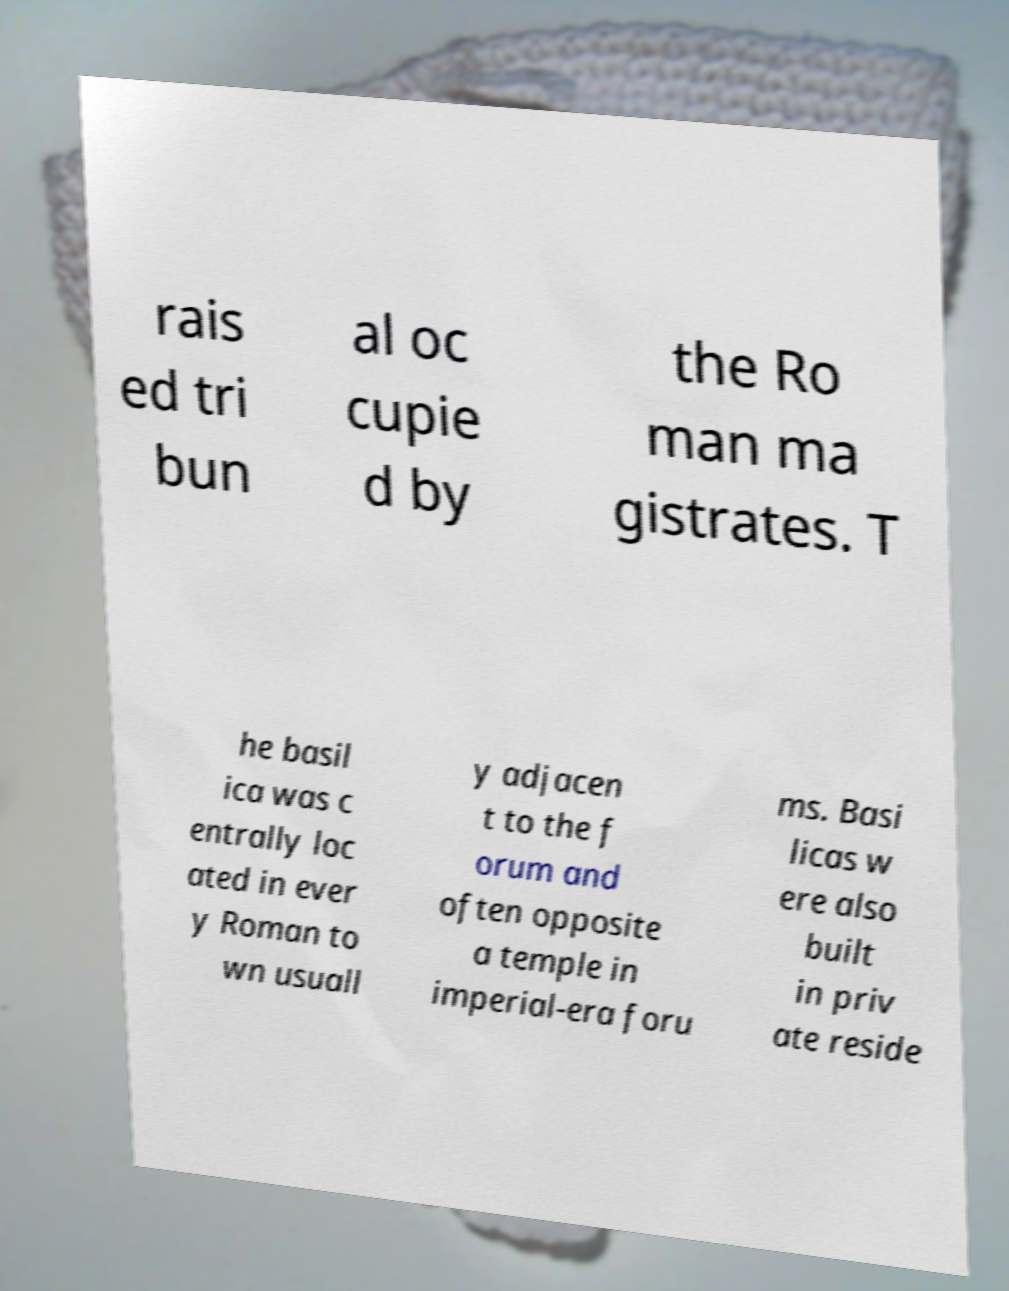Can you read and provide the text displayed in the image?This photo seems to have some interesting text. Can you extract and type it out for me? rais ed tri bun al oc cupie d by the Ro man ma gistrates. T he basil ica was c entrally loc ated in ever y Roman to wn usuall y adjacen t to the f orum and often opposite a temple in imperial-era foru ms. Basi licas w ere also built in priv ate reside 